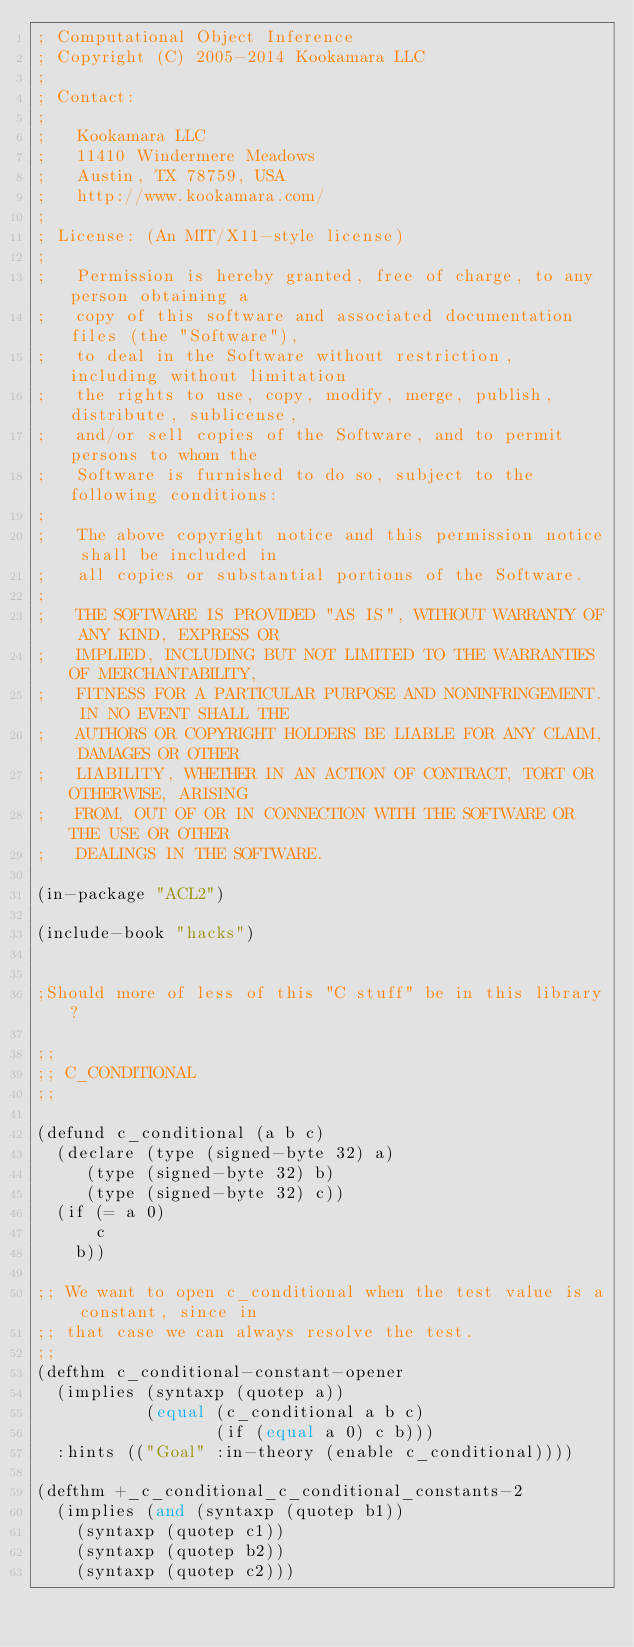<code> <loc_0><loc_0><loc_500><loc_500><_Lisp_>; Computational Object Inference
; Copyright (C) 2005-2014 Kookamara LLC
;
; Contact:
;
;   Kookamara LLC
;   11410 Windermere Meadows
;   Austin, TX 78759, USA
;   http://www.kookamara.com/
;
; License: (An MIT/X11-style license)
;
;   Permission is hereby granted, free of charge, to any person obtaining a
;   copy of this software and associated documentation files (the "Software"),
;   to deal in the Software without restriction, including without limitation
;   the rights to use, copy, modify, merge, publish, distribute, sublicense,
;   and/or sell copies of the Software, and to permit persons to whom the
;   Software is furnished to do so, subject to the following conditions:
;
;   The above copyright notice and this permission notice shall be included in
;   all copies or substantial portions of the Software.
;
;   THE SOFTWARE IS PROVIDED "AS IS", WITHOUT WARRANTY OF ANY KIND, EXPRESS OR
;   IMPLIED, INCLUDING BUT NOT LIMITED TO THE WARRANTIES OF MERCHANTABILITY,
;   FITNESS FOR A PARTICULAR PURPOSE AND NONINFRINGEMENT. IN NO EVENT SHALL THE
;   AUTHORS OR COPYRIGHT HOLDERS BE LIABLE FOR ANY CLAIM, DAMAGES OR OTHER
;   LIABILITY, WHETHER IN AN ACTION OF CONTRACT, TORT OR OTHERWISE, ARISING
;   FROM, OUT OF OR IN CONNECTION WITH THE SOFTWARE OR THE USE OR OTHER
;   DEALINGS IN THE SOFTWARE.

(in-package "ACL2")

(include-book "hacks")


;Should more of less of this "C stuff" be in this library?

;;
;; C_CONDITIONAL
;;

(defund c_conditional (a b c)
  (declare (type (signed-byte 32) a)
	   (type (signed-byte 32) b)
	   (type (signed-byte 32) c))
  (if (= a 0)
      c
    b))

;; We want to open c_conditional when the test value is a constant, since in
;; that case we can always resolve the test.
;;
(defthm c_conditional-constant-opener
  (implies (syntaxp (quotep a))
           (equal (c_conditional a b c)
                  (if (equal a 0) c b)))
  :hints (("Goal" :in-theory (enable c_conditional))))

(defthm +_c_conditional_c_conditional_constants-2
  (implies (and (syntaxp (quotep b1))
		(syntaxp (quotep c1))
		(syntaxp (quotep b2))
		(syntaxp (quotep c2)))</code> 